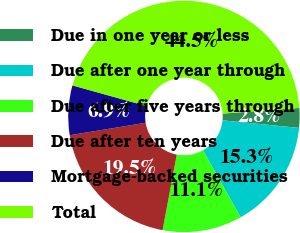Convert chart to OTSL. <chart><loc_0><loc_0><loc_500><loc_500><pie_chart><fcel>Due in one year or less<fcel>Due after one year through<fcel>Due after five years through<fcel>Due after ten years<fcel>Mortgage-backed securities<fcel>Total<nl><fcel>2.75%<fcel>15.27%<fcel>11.1%<fcel>19.45%<fcel>6.92%<fcel>44.5%<nl></chart> 